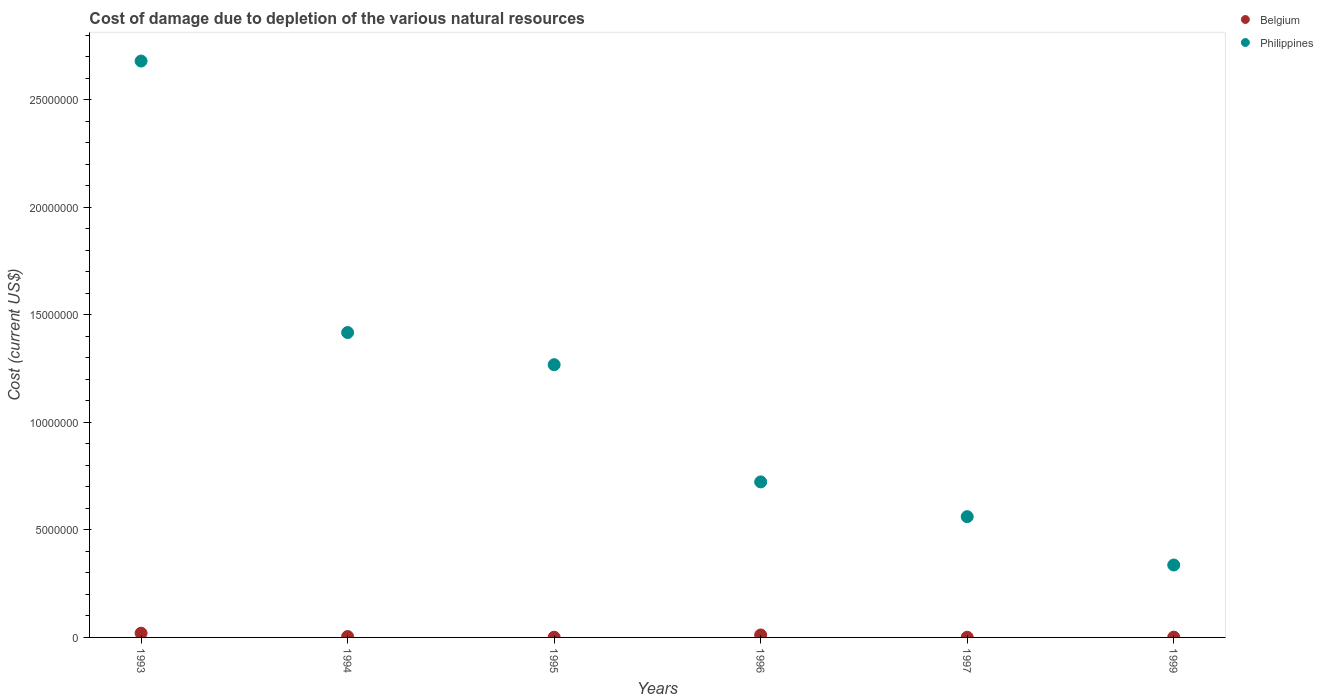Is the number of dotlines equal to the number of legend labels?
Make the answer very short. Yes. What is the cost of damage caused due to the depletion of various natural resources in Philippines in 1994?
Provide a succinct answer. 1.42e+07. Across all years, what is the maximum cost of damage caused due to the depletion of various natural resources in Philippines?
Offer a very short reply. 2.68e+07. Across all years, what is the minimum cost of damage caused due to the depletion of various natural resources in Philippines?
Keep it short and to the point. 3.37e+06. In which year was the cost of damage caused due to the depletion of various natural resources in Belgium maximum?
Make the answer very short. 1993. What is the total cost of damage caused due to the depletion of various natural resources in Philippines in the graph?
Your answer should be very brief. 6.99e+07. What is the difference between the cost of damage caused due to the depletion of various natural resources in Belgium in 1994 and that in 1995?
Give a very brief answer. 3.18e+04. What is the difference between the cost of damage caused due to the depletion of various natural resources in Philippines in 1997 and the cost of damage caused due to the depletion of various natural resources in Belgium in 1995?
Your response must be concise. 5.61e+06. What is the average cost of damage caused due to the depletion of various natural resources in Philippines per year?
Offer a terse response. 1.16e+07. In the year 1996, what is the difference between the cost of damage caused due to the depletion of various natural resources in Philippines and cost of damage caused due to the depletion of various natural resources in Belgium?
Your answer should be very brief. 7.12e+06. What is the ratio of the cost of damage caused due to the depletion of various natural resources in Belgium in 1996 to that in 1997?
Offer a very short reply. 14.89. What is the difference between the highest and the second highest cost of damage caused due to the depletion of various natural resources in Belgium?
Your answer should be compact. 8.31e+04. What is the difference between the highest and the lowest cost of damage caused due to the depletion of various natural resources in Philippines?
Keep it short and to the point. 2.34e+07. Is the sum of the cost of damage caused due to the depletion of various natural resources in Belgium in 1994 and 1999 greater than the maximum cost of damage caused due to the depletion of various natural resources in Philippines across all years?
Offer a terse response. No. Does the cost of damage caused due to the depletion of various natural resources in Belgium monotonically increase over the years?
Offer a very short reply. No. Is the cost of damage caused due to the depletion of various natural resources in Belgium strictly less than the cost of damage caused due to the depletion of various natural resources in Philippines over the years?
Keep it short and to the point. Yes. How many years are there in the graph?
Your response must be concise. 6. What is the difference between two consecutive major ticks on the Y-axis?
Your response must be concise. 5.00e+06. Are the values on the major ticks of Y-axis written in scientific E-notation?
Ensure brevity in your answer.  No. Does the graph contain any zero values?
Offer a terse response. No. Does the graph contain grids?
Give a very brief answer. No. How are the legend labels stacked?
Your answer should be compact. Vertical. What is the title of the graph?
Offer a terse response. Cost of damage due to depletion of the various natural resources. What is the label or title of the X-axis?
Your answer should be compact. Years. What is the label or title of the Y-axis?
Provide a succinct answer. Cost (current US$). What is the Cost (current US$) of Belgium in 1993?
Offer a terse response. 1.97e+05. What is the Cost (current US$) in Philippines in 1993?
Your answer should be very brief. 2.68e+07. What is the Cost (current US$) of Belgium in 1994?
Offer a very short reply. 4.19e+04. What is the Cost (current US$) of Philippines in 1994?
Offer a very short reply. 1.42e+07. What is the Cost (current US$) of Belgium in 1995?
Your answer should be very brief. 1.01e+04. What is the Cost (current US$) of Philippines in 1995?
Keep it short and to the point. 1.27e+07. What is the Cost (current US$) of Belgium in 1996?
Offer a terse response. 1.14e+05. What is the Cost (current US$) in Philippines in 1996?
Make the answer very short. 7.23e+06. What is the Cost (current US$) in Belgium in 1997?
Offer a terse response. 7664.97. What is the Cost (current US$) in Philippines in 1997?
Your response must be concise. 5.62e+06. What is the Cost (current US$) in Belgium in 1999?
Provide a succinct answer. 1.35e+04. What is the Cost (current US$) of Philippines in 1999?
Offer a terse response. 3.37e+06. Across all years, what is the maximum Cost (current US$) in Belgium?
Offer a very short reply. 1.97e+05. Across all years, what is the maximum Cost (current US$) in Philippines?
Your answer should be compact. 2.68e+07. Across all years, what is the minimum Cost (current US$) of Belgium?
Offer a very short reply. 7664.97. Across all years, what is the minimum Cost (current US$) in Philippines?
Offer a terse response. 3.37e+06. What is the total Cost (current US$) in Belgium in the graph?
Keep it short and to the point. 3.85e+05. What is the total Cost (current US$) in Philippines in the graph?
Offer a terse response. 6.99e+07. What is the difference between the Cost (current US$) in Belgium in 1993 and that in 1994?
Your response must be concise. 1.55e+05. What is the difference between the Cost (current US$) in Philippines in 1993 and that in 1994?
Provide a short and direct response. 1.26e+07. What is the difference between the Cost (current US$) in Belgium in 1993 and that in 1995?
Ensure brevity in your answer.  1.87e+05. What is the difference between the Cost (current US$) of Philippines in 1993 and that in 1995?
Your answer should be very brief. 1.41e+07. What is the difference between the Cost (current US$) of Belgium in 1993 and that in 1996?
Your answer should be compact. 8.31e+04. What is the difference between the Cost (current US$) in Philippines in 1993 and that in 1996?
Ensure brevity in your answer.  1.96e+07. What is the difference between the Cost (current US$) in Belgium in 1993 and that in 1997?
Ensure brevity in your answer.  1.90e+05. What is the difference between the Cost (current US$) of Philippines in 1993 and that in 1997?
Ensure brevity in your answer.  2.12e+07. What is the difference between the Cost (current US$) in Belgium in 1993 and that in 1999?
Offer a terse response. 1.84e+05. What is the difference between the Cost (current US$) in Philippines in 1993 and that in 1999?
Provide a succinct answer. 2.34e+07. What is the difference between the Cost (current US$) in Belgium in 1994 and that in 1995?
Provide a succinct answer. 3.18e+04. What is the difference between the Cost (current US$) of Philippines in 1994 and that in 1995?
Keep it short and to the point. 1.50e+06. What is the difference between the Cost (current US$) in Belgium in 1994 and that in 1996?
Give a very brief answer. -7.22e+04. What is the difference between the Cost (current US$) in Philippines in 1994 and that in 1996?
Make the answer very short. 6.95e+06. What is the difference between the Cost (current US$) in Belgium in 1994 and that in 1997?
Provide a succinct answer. 3.43e+04. What is the difference between the Cost (current US$) in Philippines in 1994 and that in 1997?
Provide a short and direct response. 8.56e+06. What is the difference between the Cost (current US$) of Belgium in 1994 and that in 1999?
Offer a very short reply. 2.84e+04. What is the difference between the Cost (current US$) of Philippines in 1994 and that in 1999?
Your response must be concise. 1.08e+07. What is the difference between the Cost (current US$) in Belgium in 1995 and that in 1996?
Ensure brevity in your answer.  -1.04e+05. What is the difference between the Cost (current US$) in Philippines in 1995 and that in 1996?
Your answer should be very brief. 5.45e+06. What is the difference between the Cost (current US$) of Belgium in 1995 and that in 1997?
Give a very brief answer. 2473.25. What is the difference between the Cost (current US$) in Philippines in 1995 and that in 1997?
Give a very brief answer. 7.07e+06. What is the difference between the Cost (current US$) of Belgium in 1995 and that in 1999?
Give a very brief answer. -3366.79. What is the difference between the Cost (current US$) of Philippines in 1995 and that in 1999?
Your answer should be very brief. 9.32e+06. What is the difference between the Cost (current US$) in Belgium in 1996 and that in 1997?
Your answer should be very brief. 1.06e+05. What is the difference between the Cost (current US$) of Philippines in 1996 and that in 1997?
Make the answer very short. 1.62e+06. What is the difference between the Cost (current US$) in Belgium in 1996 and that in 1999?
Your answer should be compact. 1.01e+05. What is the difference between the Cost (current US$) of Philippines in 1996 and that in 1999?
Your answer should be very brief. 3.87e+06. What is the difference between the Cost (current US$) in Belgium in 1997 and that in 1999?
Your answer should be very brief. -5840.04. What is the difference between the Cost (current US$) of Philippines in 1997 and that in 1999?
Offer a terse response. 2.25e+06. What is the difference between the Cost (current US$) in Belgium in 1993 and the Cost (current US$) in Philippines in 1994?
Provide a succinct answer. -1.40e+07. What is the difference between the Cost (current US$) in Belgium in 1993 and the Cost (current US$) in Philippines in 1995?
Your answer should be compact. -1.25e+07. What is the difference between the Cost (current US$) in Belgium in 1993 and the Cost (current US$) in Philippines in 1996?
Your response must be concise. -7.04e+06. What is the difference between the Cost (current US$) in Belgium in 1993 and the Cost (current US$) in Philippines in 1997?
Your response must be concise. -5.42e+06. What is the difference between the Cost (current US$) of Belgium in 1993 and the Cost (current US$) of Philippines in 1999?
Offer a terse response. -3.17e+06. What is the difference between the Cost (current US$) of Belgium in 1994 and the Cost (current US$) of Philippines in 1995?
Offer a very short reply. -1.26e+07. What is the difference between the Cost (current US$) of Belgium in 1994 and the Cost (current US$) of Philippines in 1996?
Ensure brevity in your answer.  -7.19e+06. What is the difference between the Cost (current US$) of Belgium in 1994 and the Cost (current US$) of Philippines in 1997?
Your response must be concise. -5.57e+06. What is the difference between the Cost (current US$) in Belgium in 1994 and the Cost (current US$) in Philippines in 1999?
Offer a very short reply. -3.33e+06. What is the difference between the Cost (current US$) of Belgium in 1995 and the Cost (current US$) of Philippines in 1996?
Make the answer very short. -7.22e+06. What is the difference between the Cost (current US$) of Belgium in 1995 and the Cost (current US$) of Philippines in 1997?
Offer a very short reply. -5.61e+06. What is the difference between the Cost (current US$) of Belgium in 1995 and the Cost (current US$) of Philippines in 1999?
Offer a very short reply. -3.36e+06. What is the difference between the Cost (current US$) in Belgium in 1996 and the Cost (current US$) in Philippines in 1997?
Give a very brief answer. -5.50e+06. What is the difference between the Cost (current US$) of Belgium in 1996 and the Cost (current US$) of Philippines in 1999?
Keep it short and to the point. -3.25e+06. What is the difference between the Cost (current US$) of Belgium in 1997 and the Cost (current US$) of Philippines in 1999?
Provide a short and direct response. -3.36e+06. What is the average Cost (current US$) of Belgium per year?
Provide a succinct answer. 6.41e+04. What is the average Cost (current US$) of Philippines per year?
Keep it short and to the point. 1.16e+07. In the year 1993, what is the difference between the Cost (current US$) in Belgium and Cost (current US$) in Philippines?
Your answer should be very brief. -2.66e+07. In the year 1994, what is the difference between the Cost (current US$) of Belgium and Cost (current US$) of Philippines?
Your answer should be very brief. -1.41e+07. In the year 1995, what is the difference between the Cost (current US$) of Belgium and Cost (current US$) of Philippines?
Give a very brief answer. -1.27e+07. In the year 1996, what is the difference between the Cost (current US$) of Belgium and Cost (current US$) of Philippines?
Your answer should be compact. -7.12e+06. In the year 1997, what is the difference between the Cost (current US$) of Belgium and Cost (current US$) of Philippines?
Your answer should be compact. -5.61e+06. In the year 1999, what is the difference between the Cost (current US$) in Belgium and Cost (current US$) in Philippines?
Keep it short and to the point. -3.35e+06. What is the ratio of the Cost (current US$) in Belgium in 1993 to that in 1994?
Your answer should be compact. 4.7. What is the ratio of the Cost (current US$) of Philippines in 1993 to that in 1994?
Give a very brief answer. 1.89. What is the ratio of the Cost (current US$) of Belgium in 1993 to that in 1995?
Your answer should be compact. 19.45. What is the ratio of the Cost (current US$) of Philippines in 1993 to that in 1995?
Provide a succinct answer. 2.11. What is the ratio of the Cost (current US$) in Belgium in 1993 to that in 1996?
Ensure brevity in your answer.  1.73. What is the ratio of the Cost (current US$) of Philippines in 1993 to that in 1996?
Offer a very short reply. 3.71. What is the ratio of the Cost (current US$) in Belgium in 1993 to that in 1997?
Offer a terse response. 25.73. What is the ratio of the Cost (current US$) of Philippines in 1993 to that in 1997?
Your response must be concise. 4.77. What is the ratio of the Cost (current US$) of Belgium in 1993 to that in 1999?
Ensure brevity in your answer.  14.6. What is the ratio of the Cost (current US$) of Philippines in 1993 to that in 1999?
Offer a terse response. 7.96. What is the ratio of the Cost (current US$) of Belgium in 1994 to that in 1995?
Your answer should be very brief. 4.14. What is the ratio of the Cost (current US$) of Philippines in 1994 to that in 1995?
Keep it short and to the point. 1.12. What is the ratio of the Cost (current US$) of Belgium in 1994 to that in 1996?
Provide a short and direct response. 0.37. What is the ratio of the Cost (current US$) in Philippines in 1994 to that in 1996?
Your answer should be compact. 1.96. What is the ratio of the Cost (current US$) in Belgium in 1994 to that in 1997?
Your answer should be compact. 5.47. What is the ratio of the Cost (current US$) in Philippines in 1994 to that in 1997?
Provide a short and direct response. 2.52. What is the ratio of the Cost (current US$) of Belgium in 1994 to that in 1999?
Keep it short and to the point. 3.11. What is the ratio of the Cost (current US$) of Philippines in 1994 to that in 1999?
Keep it short and to the point. 4.21. What is the ratio of the Cost (current US$) in Belgium in 1995 to that in 1996?
Keep it short and to the point. 0.09. What is the ratio of the Cost (current US$) in Philippines in 1995 to that in 1996?
Offer a very short reply. 1.75. What is the ratio of the Cost (current US$) of Belgium in 1995 to that in 1997?
Your response must be concise. 1.32. What is the ratio of the Cost (current US$) of Philippines in 1995 to that in 1997?
Keep it short and to the point. 2.26. What is the ratio of the Cost (current US$) of Belgium in 1995 to that in 1999?
Your response must be concise. 0.75. What is the ratio of the Cost (current US$) of Philippines in 1995 to that in 1999?
Provide a succinct answer. 3.77. What is the ratio of the Cost (current US$) in Belgium in 1996 to that in 1997?
Provide a succinct answer. 14.89. What is the ratio of the Cost (current US$) in Philippines in 1996 to that in 1997?
Give a very brief answer. 1.29. What is the ratio of the Cost (current US$) in Belgium in 1996 to that in 1999?
Your response must be concise. 8.45. What is the ratio of the Cost (current US$) of Philippines in 1996 to that in 1999?
Offer a terse response. 2.15. What is the ratio of the Cost (current US$) in Belgium in 1997 to that in 1999?
Give a very brief answer. 0.57. What is the ratio of the Cost (current US$) in Philippines in 1997 to that in 1999?
Ensure brevity in your answer.  1.67. What is the difference between the highest and the second highest Cost (current US$) of Belgium?
Make the answer very short. 8.31e+04. What is the difference between the highest and the second highest Cost (current US$) of Philippines?
Keep it short and to the point. 1.26e+07. What is the difference between the highest and the lowest Cost (current US$) of Belgium?
Your response must be concise. 1.90e+05. What is the difference between the highest and the lowest Cost (current US$) in Philippines?
Keep it short and to the point. 2.34e+07. 